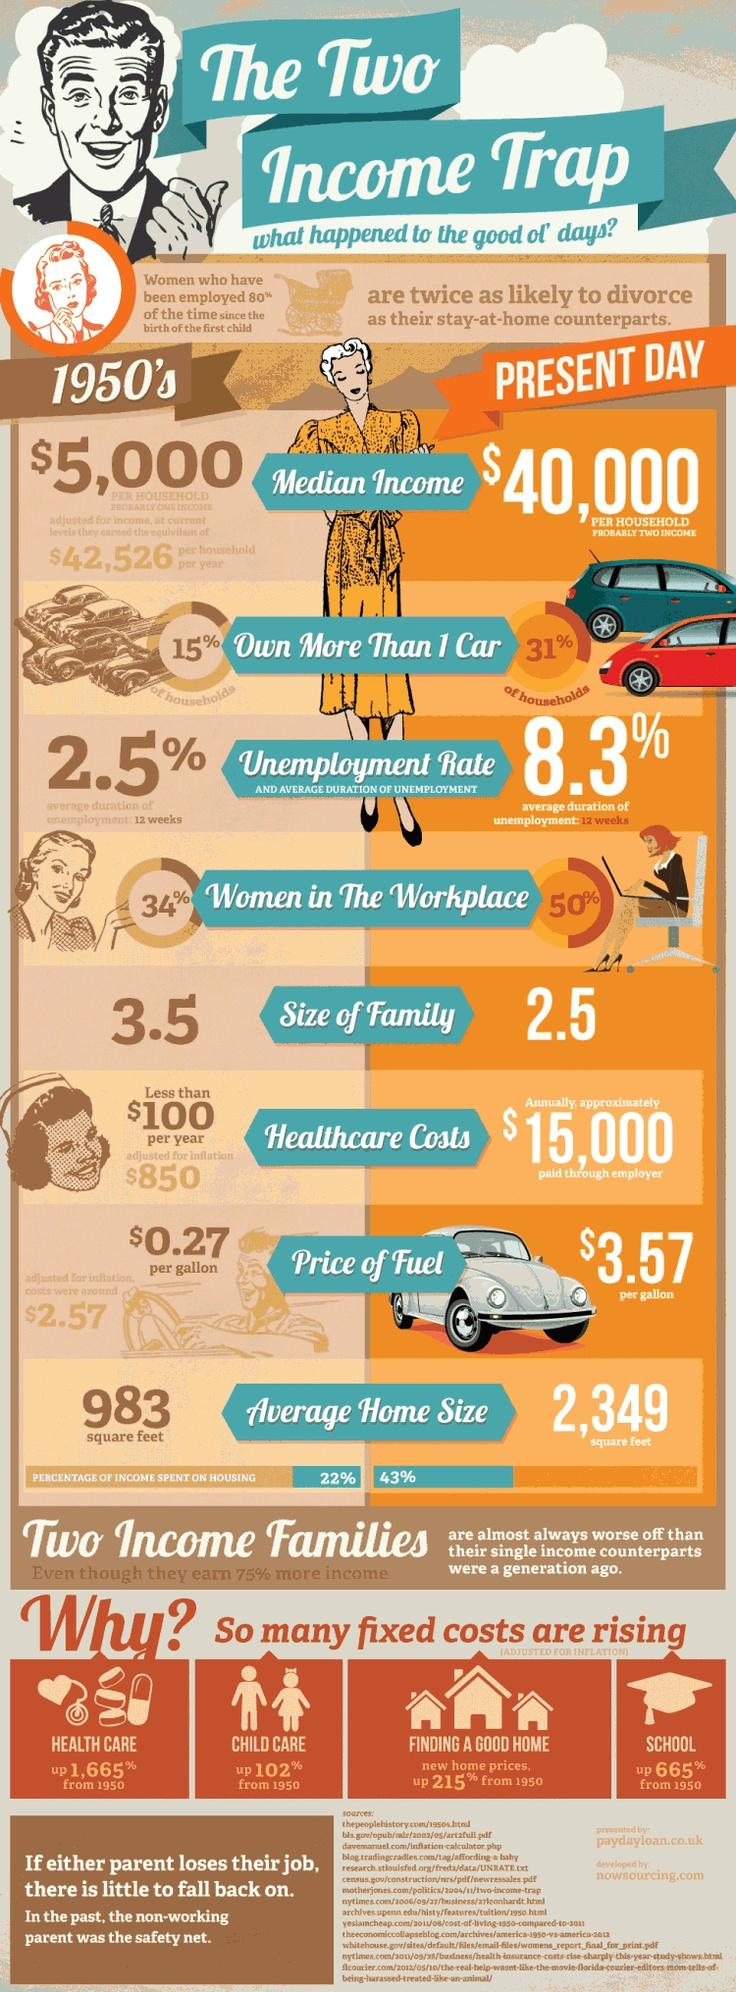Mention a couple of crucial points in this snapshot. Individuals or families who earn 75% more income than the average are typically part of two-income families. The comparison table between the 1950s and the present day highlights that unemployment rate is the third item mentioned. The cost of schooling has increased by a significant percentage. The cost of health care has increased the most compared to the 1950s. From 1950, child care has increased by 102%. 